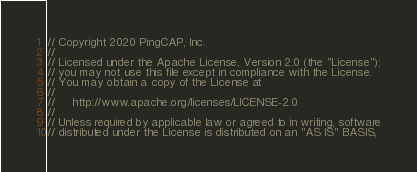<code> <loc_0><loc_0><loc_500><loc_500><_Go_>// Copyright 2020 PingCAP, Inc.
//
// Licensed under the Apache License, Version 2.0 (the "License");
// you may not use this file except in compliance with the License.
// You may obtain a copy of the License at
//
//     http://www.apache.org/licenses/LICENSE-2.0
//
// Unless required by applicable law or agreed to in writing, software
// distributed under the License is distributed on an "AS IS" BASIS,</code> 